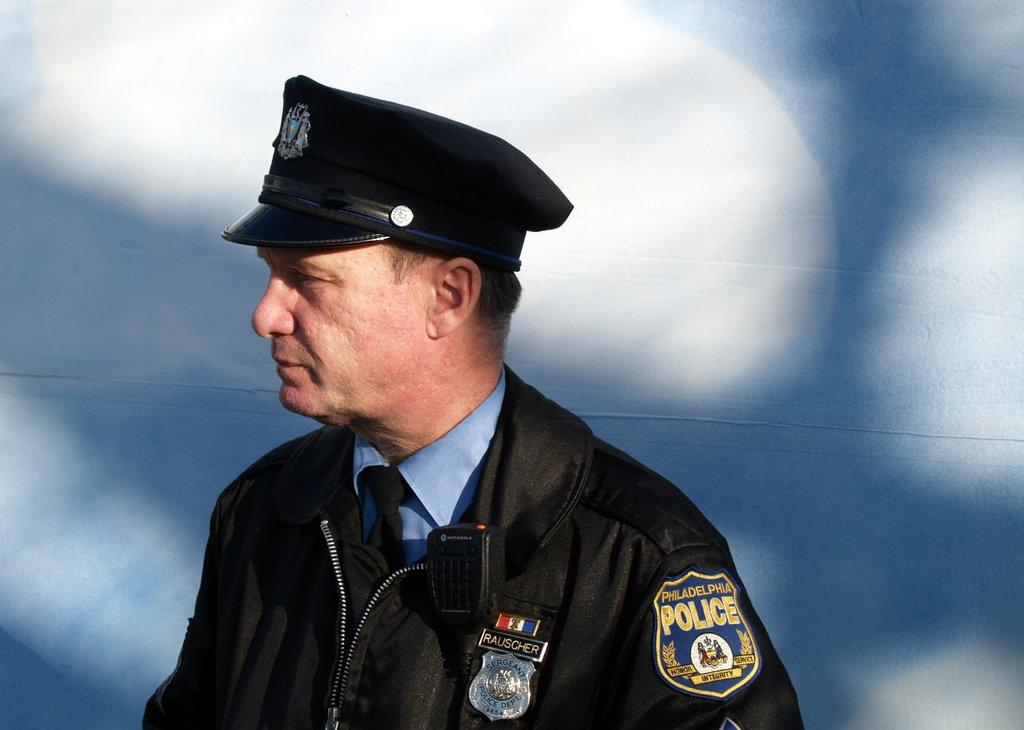What is the main subject of the image? There is a person in the image. What color is the shirt the person is wearing? The person is wearing a blue shirt. What type of accessories is the person wearing? The person is wearing a black tie, a black jacket, and a black hat. What color is the wall in the background of the image? The wall in the background of the image is white. What joke is the person telling in the image? There is no indication of a joke being told in the image. What is the name of the person in the image? The name of the person in the image is not mentioned or visible. 